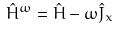Convert formula to latex. <formula><loc_0><loc_0><loc_500><loc_500>\hat { H } ^ { \omega } = \hat { H } - \omega \hat { J } _ { x }</formula> 